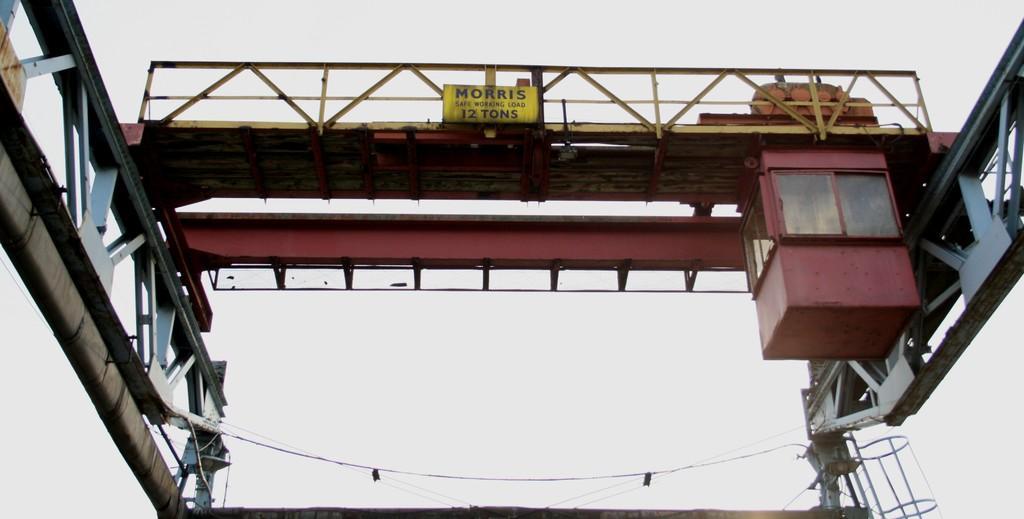Please provide a concise description of this image. In this image, we can see a bridge and we can see some wires and there is a board. 